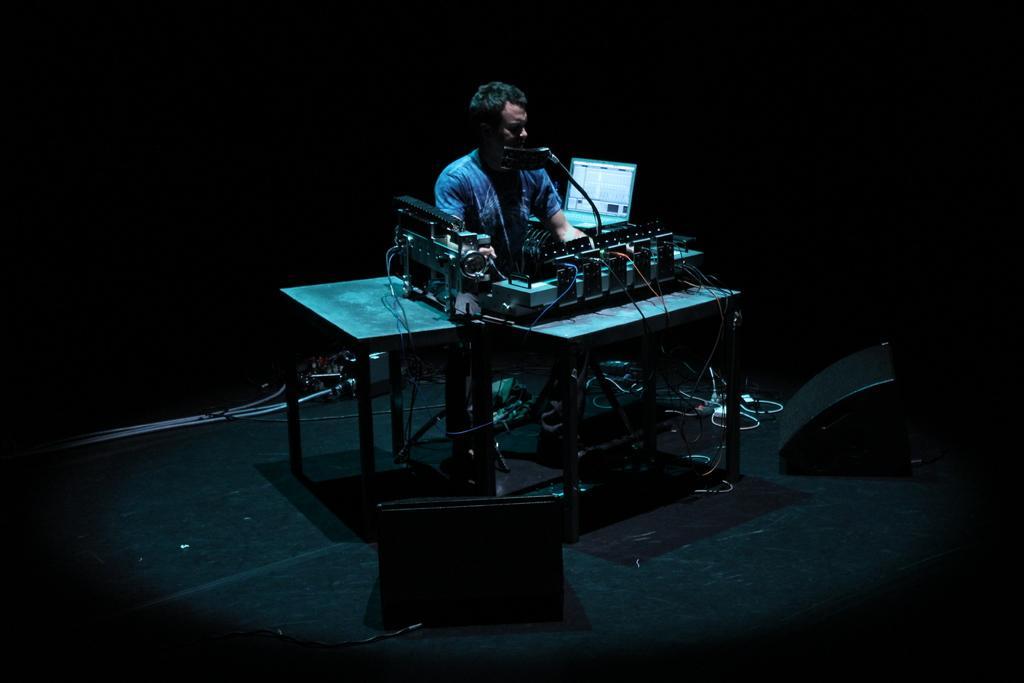Please provide a concise description of this image. In this image I can see the stage and on the stage I can see two black colored objects, few tables and on the tables I can see few electronic equipment, few wires and a laptop. I can see a person wearing blue colored dress is sitting in front of the table and I can see the black colored background. 